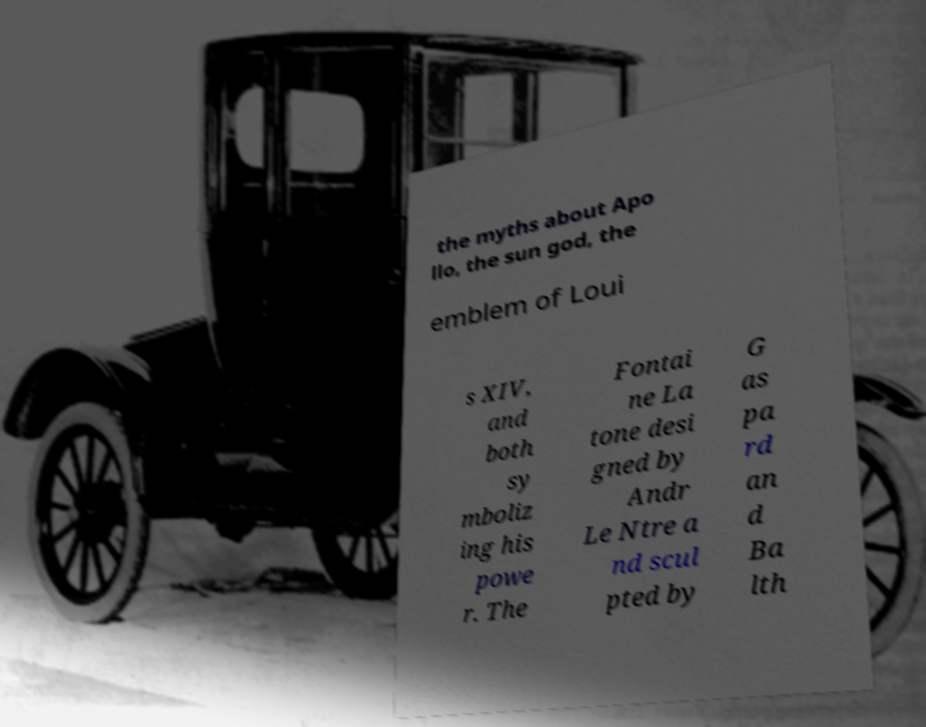Could you extract and type out the text from this image? the myths about Apo llo, the sun god, the emblem of Loui s XIV, and both sy mboliz ing his powe r. The Fontai ne La tone desi gned by Andr Le Ntre a nd scul pted by G as pa rd an d Ba lth 